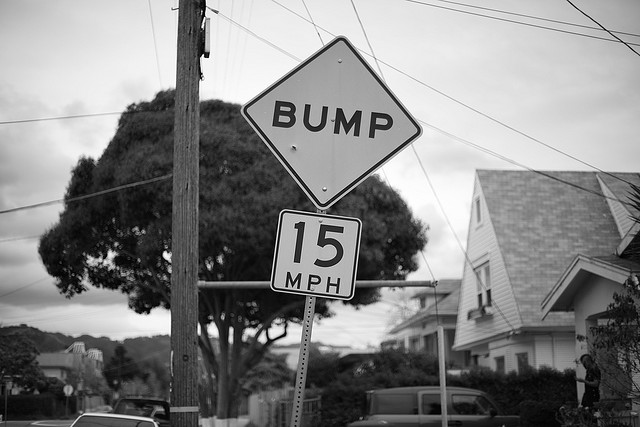Read all the text in this image. BUMP 15 MPH 